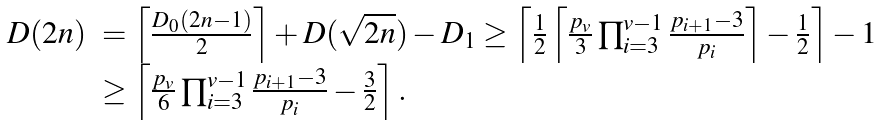Convert formula to latex. <formula><loc_0><loc_0><loc_500><loc_500>\begin{array} { r l } D ( 2 n ) & = \left \lceil \frac { D _ { 0 } ( 2 n - 1 ) } { 2 } \right \rceil + D ( \sqrt { 2 n } ) - D _ { 1 } \geq \left \lceil \frac { 1 } { 2 } \left \lceil \frac { p _ { v } } { 3 } \prod _ { i = 3 } ^ { v - 1 } \frac { p _ { i + 1 } - 3 } { p _ { i } } \right \rceil - \frac { 1 } { 2 } \right \rceil - 1 \\ & \geq \left \lceil \frac { p _ { v } } { 6 } \prod _ { i = 3 } ^ { v - 1 } \frac { p _ { i + 1 } - 3 } { p _ { i } } - \frac { 3 } { 2 } \right \rceil . \end{array}</formula> 